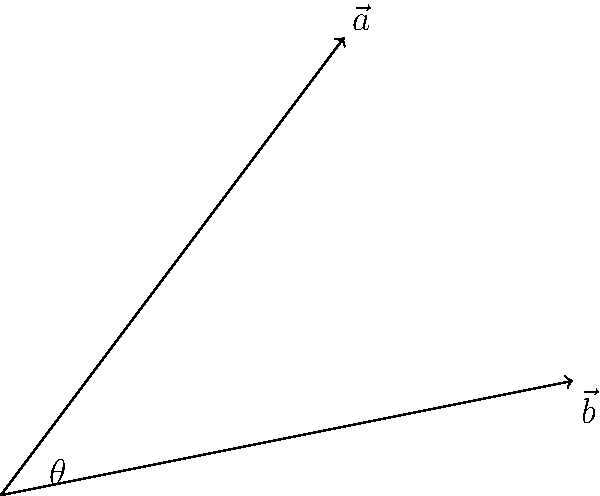In your doll-making process, you need to position two wooden limbs at a specific angle. Given two vectors $\vec{a} = \langle 3, 4 \rangle$ and $\vec{b} = \langle 5, 1 \rangle$ representing the directions of these limbs, calculate the angle $\theta$ between them to the nearest degree. To find the angle between two vectors, we can use the dot product formula:

$$\cos \theta = \frac{\vec{a} \cdot \vec{b}}{|\vec{a}||\vec{b}|}$$

Step 1: Calculate the dot product $\vec{a} \cdot \vec{b}$
$$\vec{a} \cdot \vec{b} = (3)(5) + (4)(1) = 15 + 4 = 19$$

Step 2: Calculate the magnitudes of $\vec{a}$ and $\vec{b}$
$$|\vec{a}| = \sqrt{3^2 + 4^2} = \sqrt{9 + 16} = \sqrt{25} = 5$$
$$|\vec{b}| = \sqrt{5^2 + 1^2} = \sqrt{25 + 1} = \sqrt{26}$$

Step 3: Substitute into the formula
$$\cos \theta = \frac{19}{5\sqrt{26}}$$

Step 4: Take the inverse cosine (arccos) of both sides
$$\theta = \arccos\left(\frac{19}{5\sqrt{26}}\right)$$

Step 5: Calculate and round to the nearest degree
$$\theta \approx 44.42^\circ \approx 44^\circ$$
Answer: 44° 